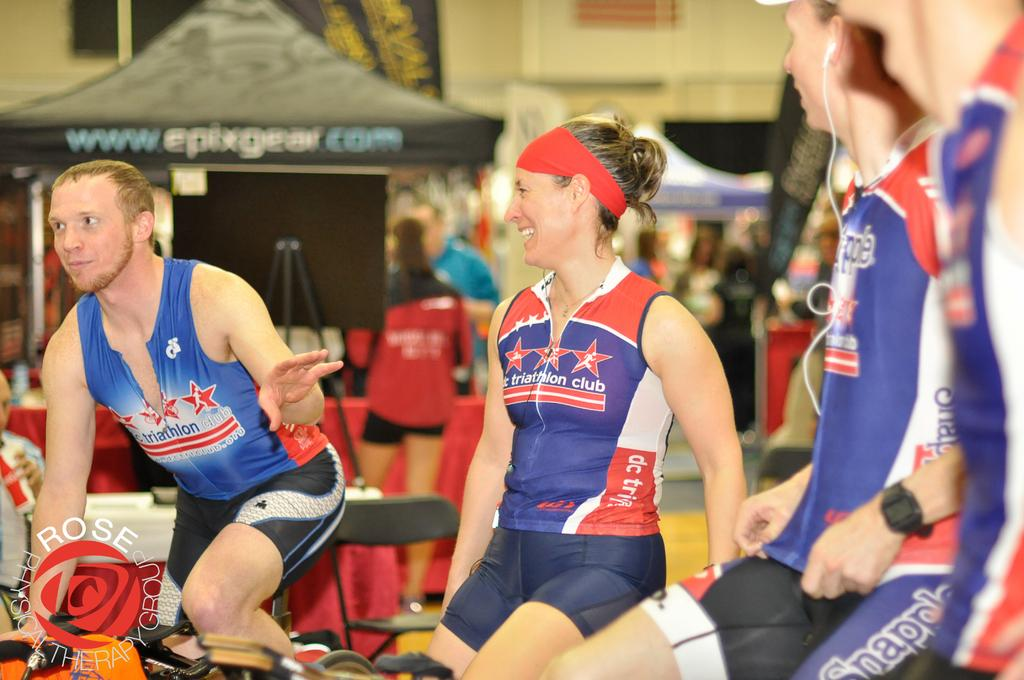<image>
Share a concise interpretation of the image provided. Women from a triathalon club are chatting and sitting on bikes. 